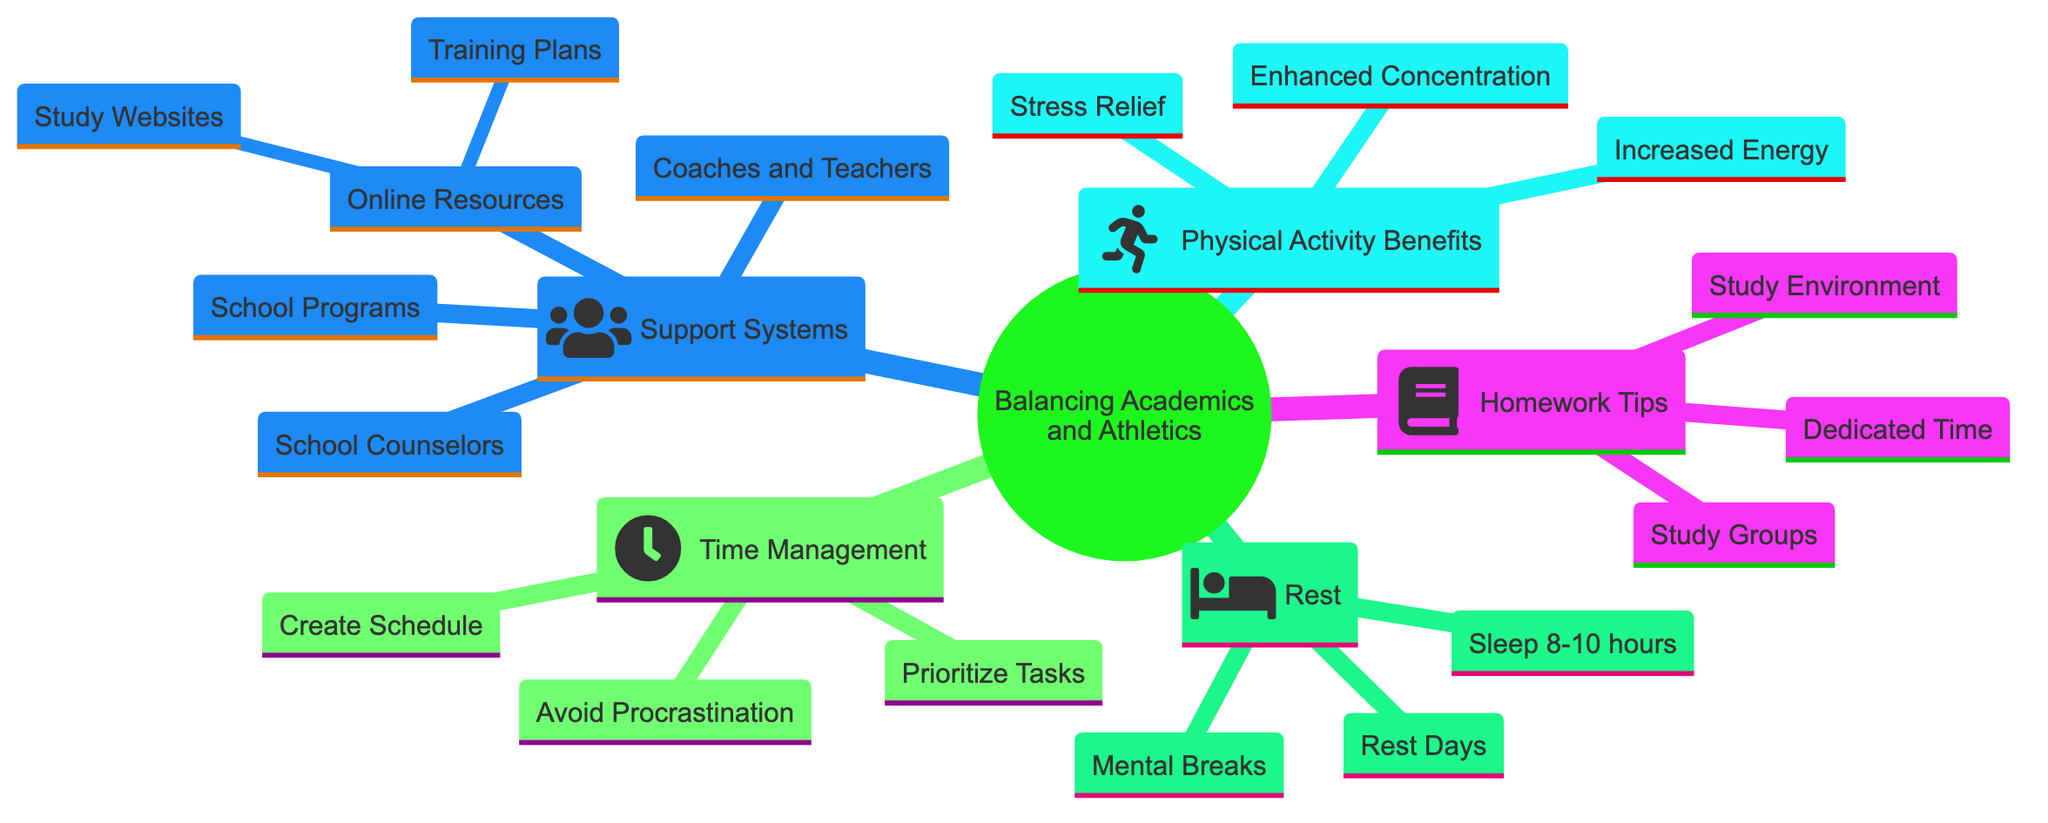What are three time management strategies listed in the diagram? The diagram lists three strategies under the Time Management section: Create Schedule, Prioritize Tasks, and Avoid Procrastination.
Answer: Create Schedule, Prioritize Tasks, Avoid Procrastination How many tips are provided under Homework Tips? The diagram includes three tips in the Homework Tips section: Dedicated Homework Time, Study Environment, and Study Groups. Hence, there are three tips in total.
Answer: 3 What is one benefit of physical activity on learning? One of the benefits listed in the diagram is Enhanced Concentration. This benefit highlights how physical activity can improve mental focus and cognitive ability.
Answer: Enhanced Concentration Which support system involves communication with coaches and teachers? The Support Systems section indicates that communicating with Coaches and Teachers is essential for balancing academic and athletic commitments.
Answer: Coaches and Teachers What should high school athletes aim for in terms of sleep hours? The Importance of Rest node states that high school athletes should aim for 8-10 hours of sleep per night for optimal performance.
Answer: 8-10 hours How do rest days contribute to student-athletes' performance? According to the diagram, including Rest Days in training helps prevent burnout, which is crucial for maintaining overall performance levels.
Answer: Prevent burnout What online resources are mentioned in the support systems section? The Support Systems section mentions Study Skills Websites such as Khan Academy and Quizlet, and Fitness and Training Plans from Rugby Australia, highlighting the available online resources.
Answer: Study Skills Websites, Fitness and Training Plans Which time management strategy helps in setting specific daily responsibilities? The Create Schedule strategy emphasizes the importance of planning out one's week, helping to set daily responsibilities and manage time effectively.
Answer: Create Schedule What is a key factor to maintain concentration during study sessions? The Importance of Rest section mentions taking Mental Breaks during study sessions as a key factor to maintain concentration and focus.
Answer: Mental Breaks 